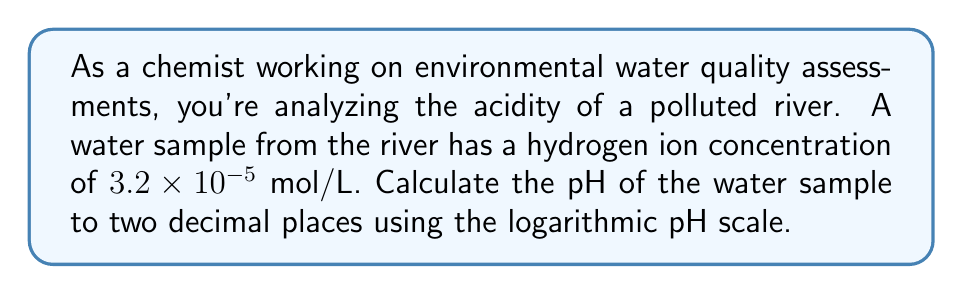Provide a solution to this math problem. To solve this problem, we'll use the logarithmic pH scale, which is defined as:

$$ pH = -\log_{10}[H^+] $$

Where $[H^+]$ is the concentration of hydrogen ions in mol/L.

Given:
$[H^+] = 3.2 \times 10^{-5}$ mol/L

Step 1: Substitute the given hydrogen ion concentration into the pH equation.
$$ pH = -\log_{10}(3.2 \times 10^{-5}) $$

Step 2: Use the logarithm properties to simplify the calculation.
$$ pH = -(\log_{10}(3.2) + \log_{10}(10^{-5})) $$

Step 3: Calculate the logarithm of 3.2 and simplify.
$$ pH = -(0.5051 - 5) $$

Step 4: Perform the subtraction inside the parentheses.
$$ pH = -(-4.4949) $$

Step 5: Remove the double negative.
$$ pH = 4.4949 $$

Step 6: Round to two decimal places.
$$ pH = 4.49 $$
Answer: The pH of the water sample is 4.49. 